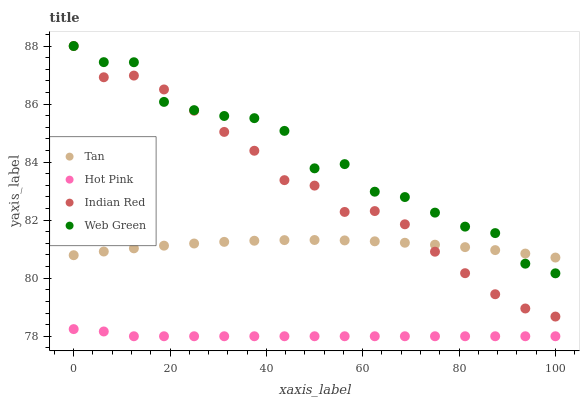Does Hot Pink have the minimum area under the curve?
Answer yes or no. Yes. Does Web Green have the maximum area under the curve?
Answer yes or no. Yes. Does Web Green have the minimum area under the curve?
Answer yes or no. No. Does Hot Pink have the maximum area under the curve?
Answer yes or no. No. Is Hot Pink the smoothest?
Answer yes or no. Yes. Is Web Green the roughest?
Answer yes or no. Yes. Is Web Green the smoothest?
Answer yes or no. No. Is Hot Pink the roughest?
Answer yes or no. No. Does Hot Pink have the lowest value?
Answer yes or no. Yes. Does Web Green have the lowest value?
Answer yes or no. No. Does Indian Red have the highest value?
Answer yes or no. Yes. Does Hot Pink have the highest value?
Answer yes or no. No. Is Hot Pink less than Indian Red?
Answer yes or no. Yes. Is Web Green greater than Hot Pink?
Answer yes or no. Yes. Does Web Green intersect Indian Red?
Answer yes or no. Yes. Is Web Green less than Indian Red?
Answer yes or no. No. Is Web Green greater than Indian Red?
Answer yes or no. No. Does Hot Pink intersect Indian Red?
Answer yes or no. No. 